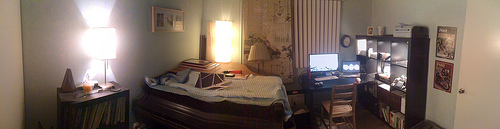Please provide a short description for this region: [0.16, 0.37, 0.24, 0.53]. This viewing area captures an intense illumination on the wall, possibly from an artificial source nearby, casting a strong, bright light against a surface that appears otherwise dimly lit. 